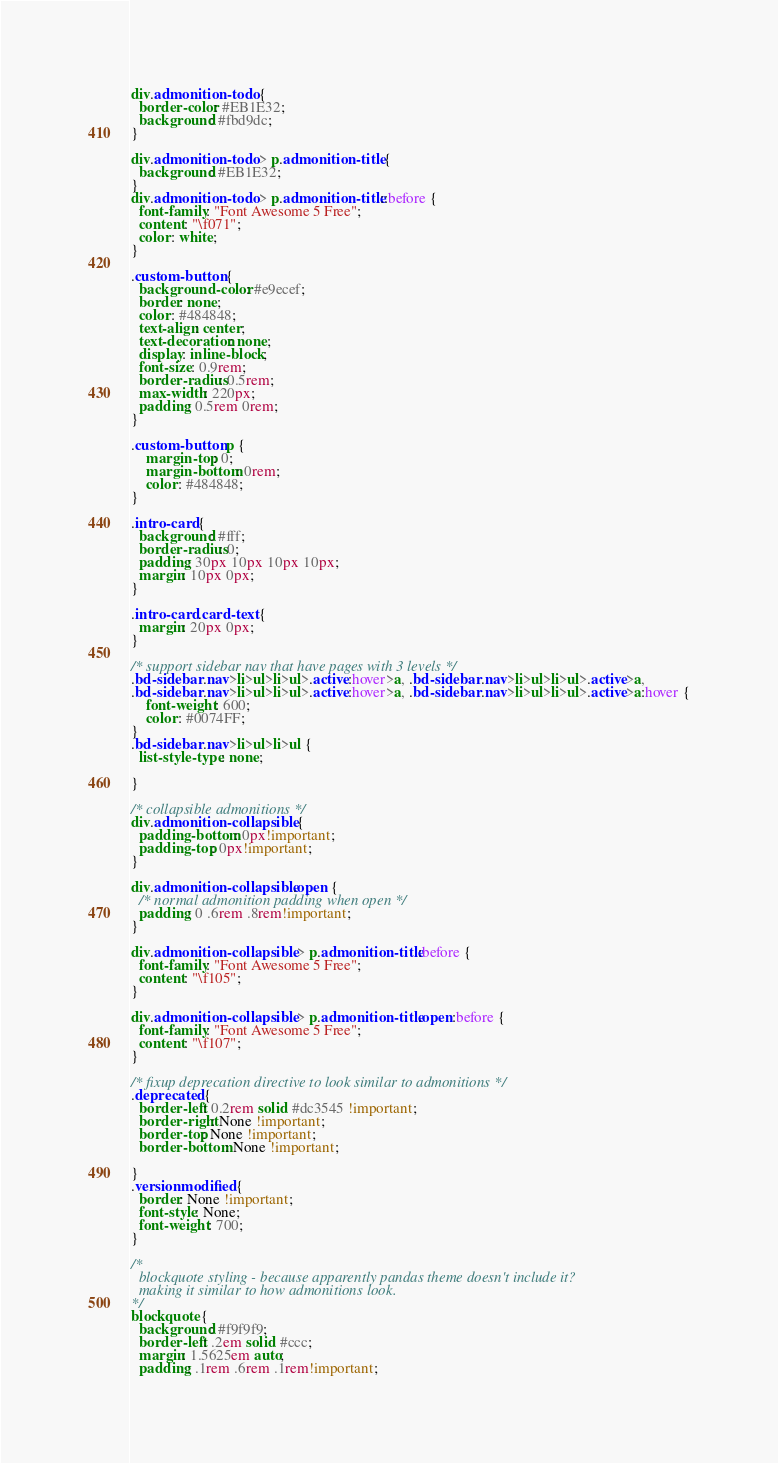Convert code to text. <code><loc_0><loc_0><loc_500><loc_500><_CSS_>div.admonition-todo {
  border-color: #EB1E32;
  background: #fbd9dc;
}

div.admonition-todo > p.admonition-title {
  background: #EB1E32;
}
div.admonition-todo > p.admonition-title::before {
  font-family: "Font Awesome 5 Free";
  content: "\f071";
  color: white;
}

.custom-button {
  background-color: #e9ecef;
  border: none;
  color: #484848;
  text-align: center;
  text-decoration: none;
  display: inline-block;
  font-size: 0.9rem;
  border-radius: 0.5rem;
  max-width: 220px;
  padding: 0.5rem 0rem;
}

.custom-button p {
    margin-top: 0;
    margin-bottom: 0rem;
    color: #484848;
}

.intro-card {
  background: #fff;
  border-radius: 0;
  padding: 30px 10px 10px 10px;
  margin: 10px 0px;
}

.intro-card .card-text {
  margin: 20px 0px;
}

/* support sidebar nav that have pages with 3 levels */
.bd-sidebar .nav>li>ul>li>ul>.active:hover>a, .bd-sidebar .nav>li>ul>li>ul>.active>a,
.bd-sidebar .nav>li>ul>li>ul>.active:hover>a, .bd-sidebar .nav>li>ul>li>ul>.active>a:hover {
    font-weight: 600;
    color: #0074FF;
}
.bd-sidebar .nav>li>ul>li>ul {
  list-style-type: none;

}

/* collapsible admonitions */
div.admonition-collapsible {
  padding-bottom: 0px!important;
  padding-top: 0px!important;
}

div.admonition-collapsible.open {
  /* normal admonition padding when open */
  padding: 0 .6rem .8rem!important;
}

div.admonition-collapsible > p.admonition-title:before {
  font-family: "Font Awesome 5 Free";
  content: "\f105";
}

div.admonition-collapsible > p.admonition-title.open:before {
  font-family: "Font Awesome 5 Free";
  content: "\f107";
}

/* fixup deprecation directive to look similar to admonitions */
.deprecated {
  border-left: 0.2rem solid #dc3545 !important;
  border-right: None !important;
  border-top: None !important;
  border-bottom: None !important;

}
.versionmodified {
  border: None !important;
  font-style: None;
  font-weight: 700;
}

/*
  blockquote styling - because apparently pandas theme doesn't include it?
  making it similar to how admonitions look.
*/
blockquote {
  background: #f9f9f9;
  border-left: .2em solid #ccc;
  margin: 1.5625em auto;
  padding: .1rem .6rem .1rem!important;</code> 